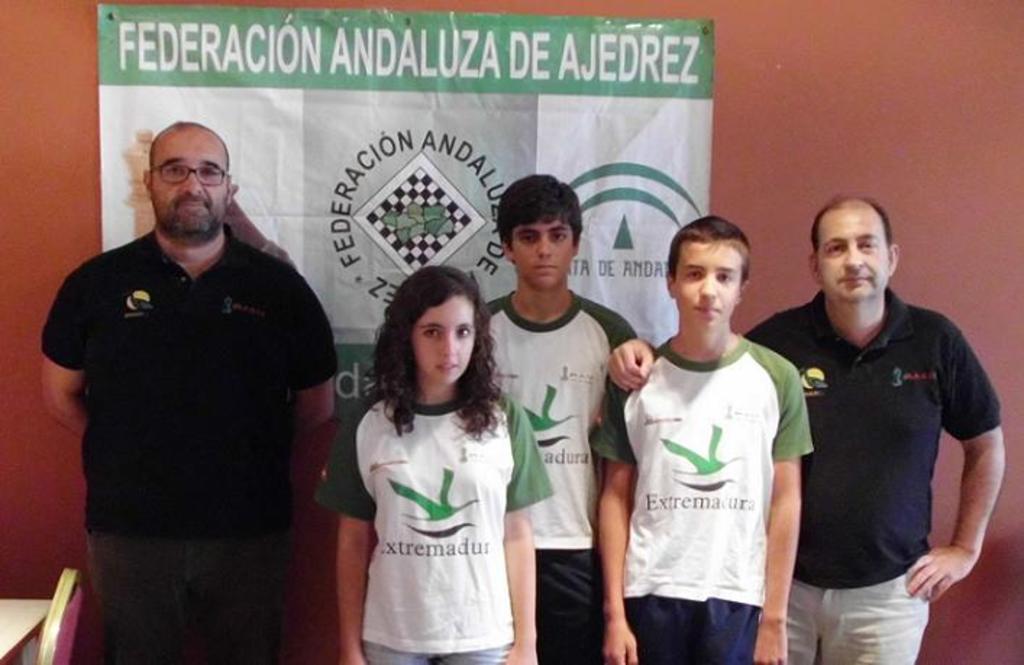Is the text in english?
Give a very brief answer. No. 